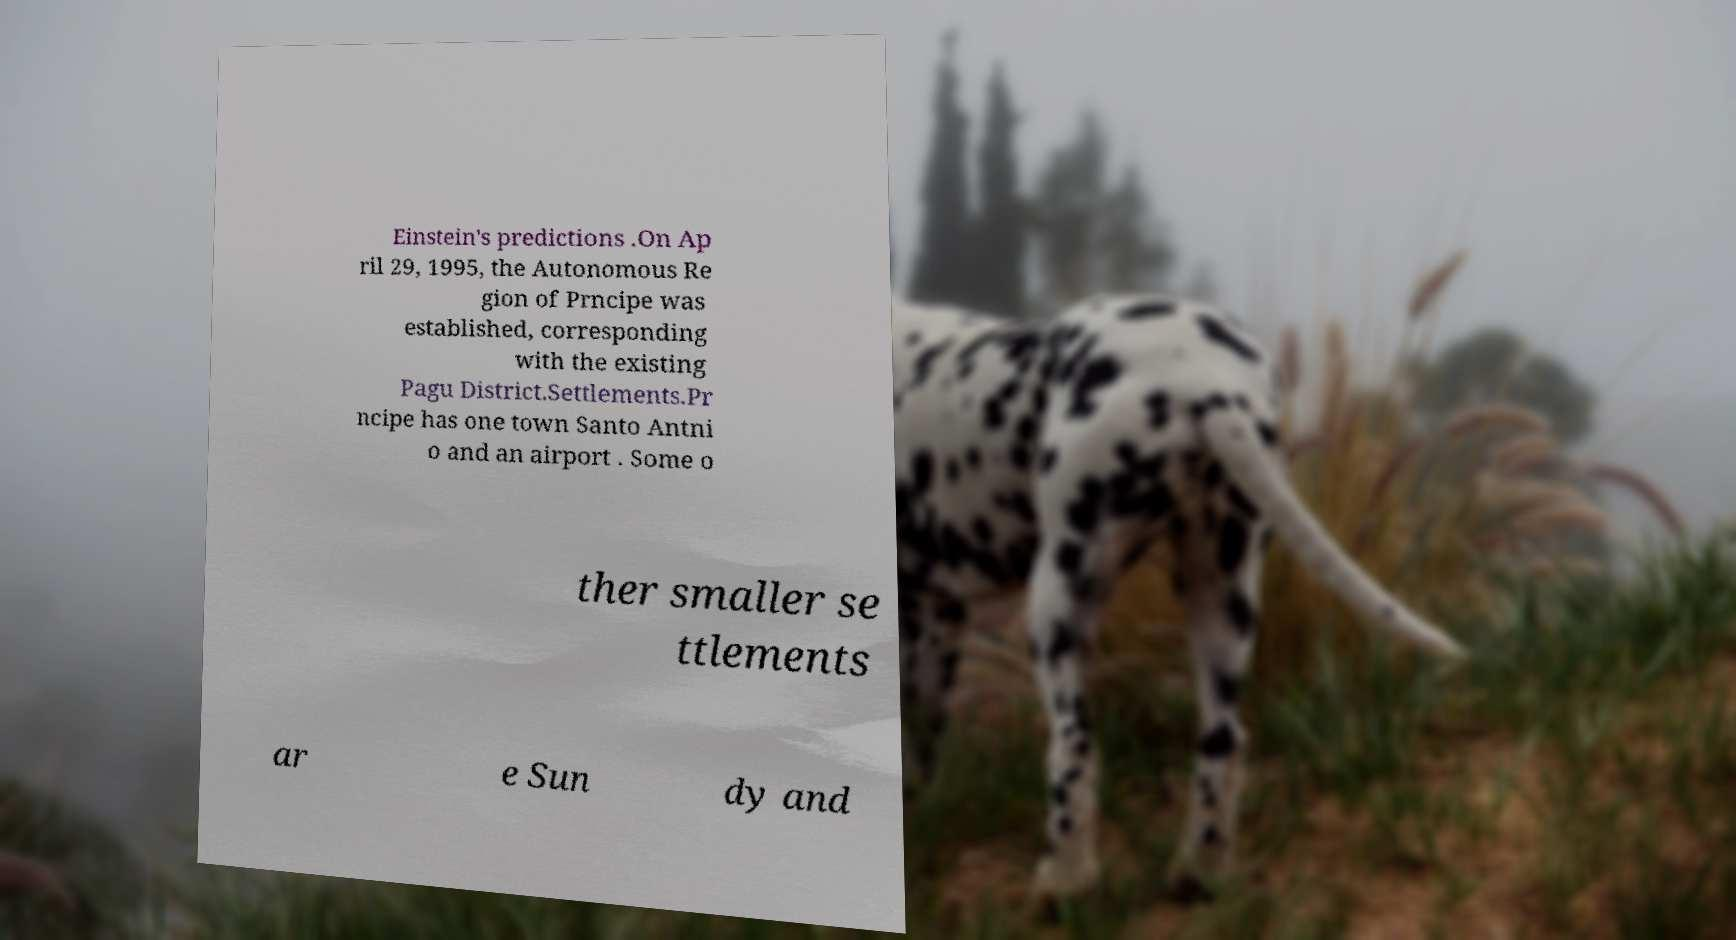Can you accurately transcribe the text from the provided image for me? Einstein's predictions .On Ap ril 29, 1995, the Autonomous Re gion of Prncipe was established, corresponding with the existing Pagu District.Settlements.Pr ncipe has one town Santo Antni o and an airport . Some o ther smaller se ttlements ar e Sun dy and 